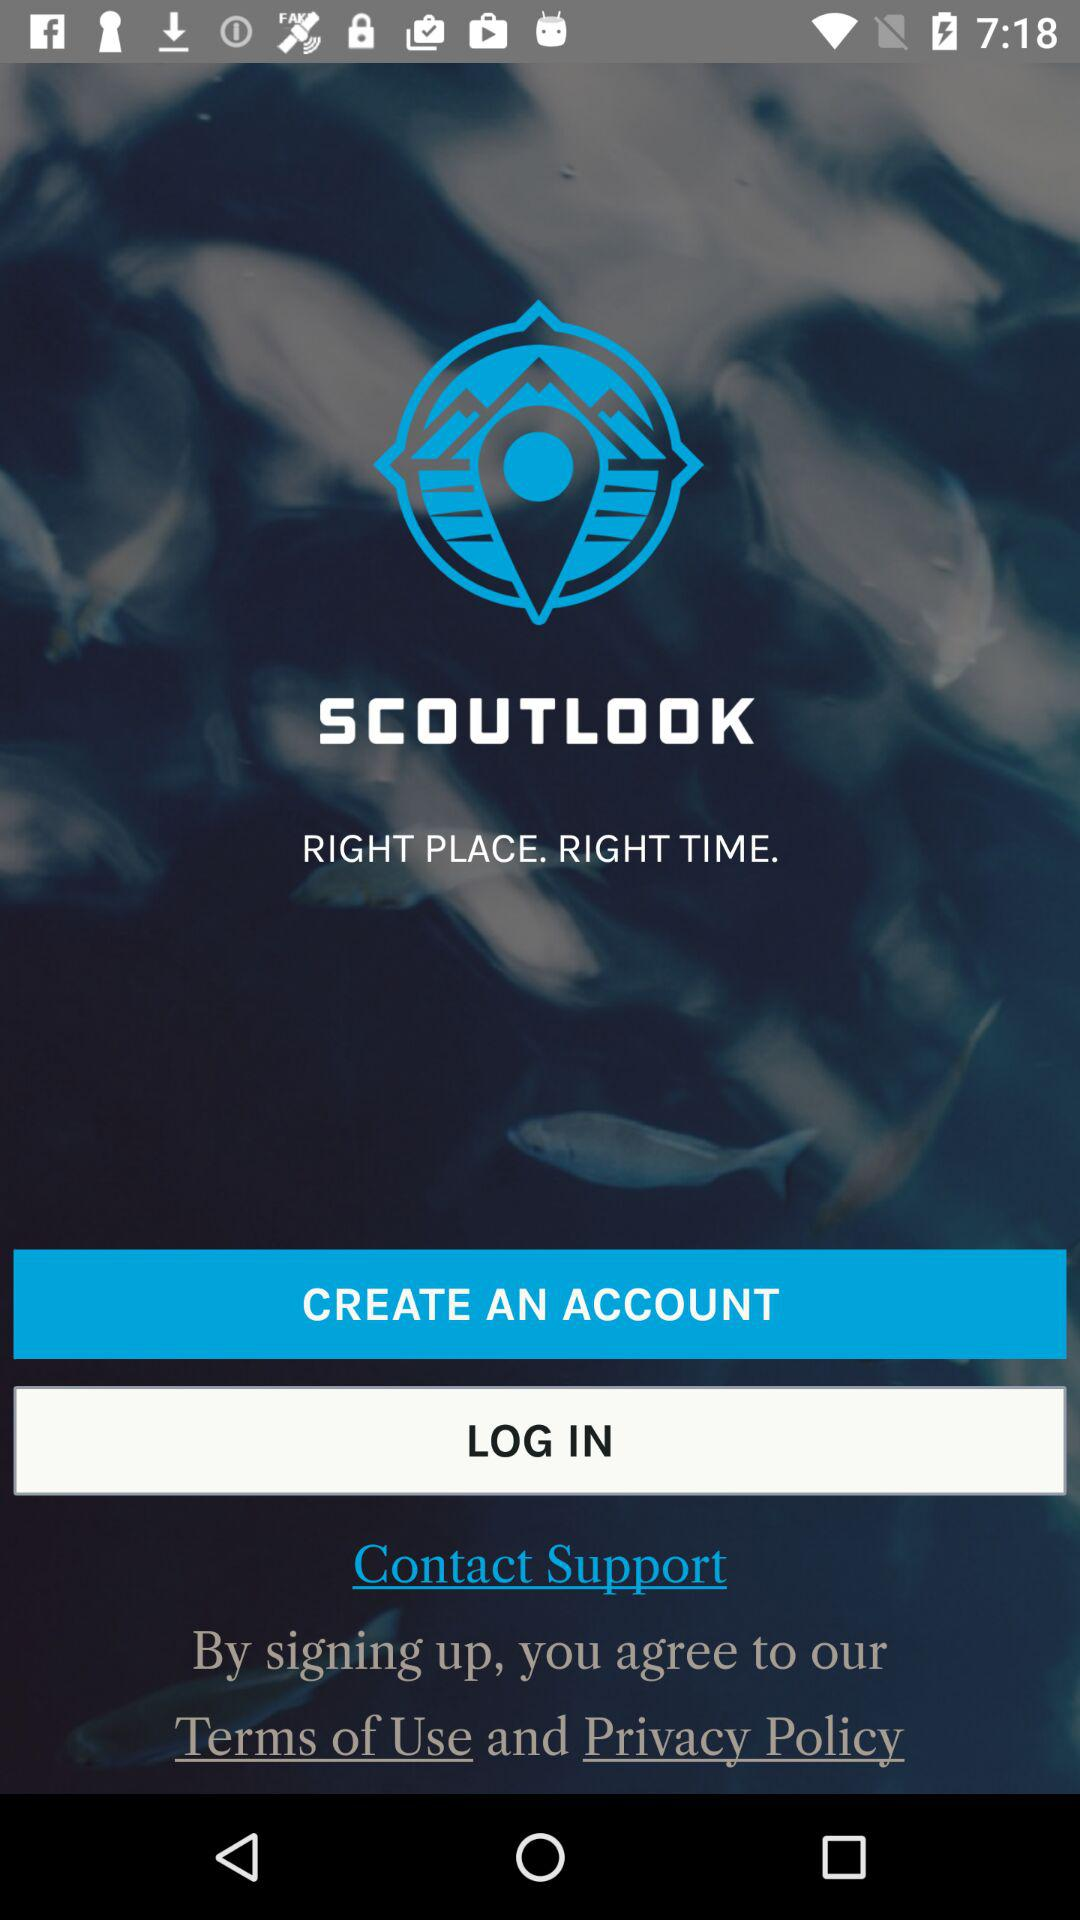What is the name of the application? The name of the application is "SCOUTLOOK". 